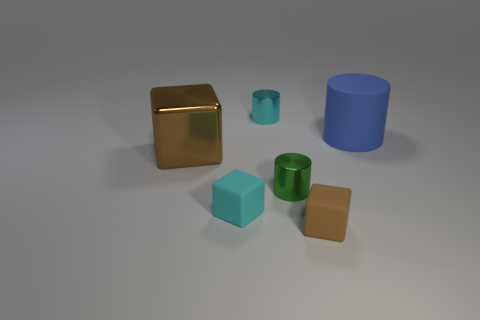There is a metallic thing that is in front of the cyan cylinder and left of the green cylinder; what size is it?
Give a very brief answer. Large. The small green thing has what shape?
Offer a very short reply. Cylinder. What number of tiny brown matte things have the same shape as the cyan matte object?
Offer a terse response. 1. Are there fewer green shiny cylinders behind the green metal object than tiny rubber things in front of the brown shiny object?
Your response must be concise. Yes. What number of metal objects are to the right of the brown thing behind the brown matte cube?
Your answer should be very brief. 2. Is there a yellow cube?
Offer a very short reply. No. Are there any tiny cubes made of the same material as the large blue cylinder?
Make the answer very short. Yes. Are there more tiny shiny objects to the right of the cyan cylinder than green cylinders behind the brown shiny thing?
Offer a terse response. Yes. Is the size of the blue rubber thing the same as the green cylinder?
Give a very brief answer. No. What color is the small rubber block on the left side of the brown object that is to the right of the small green cylinder?
Make the answer very short. Cyan. 